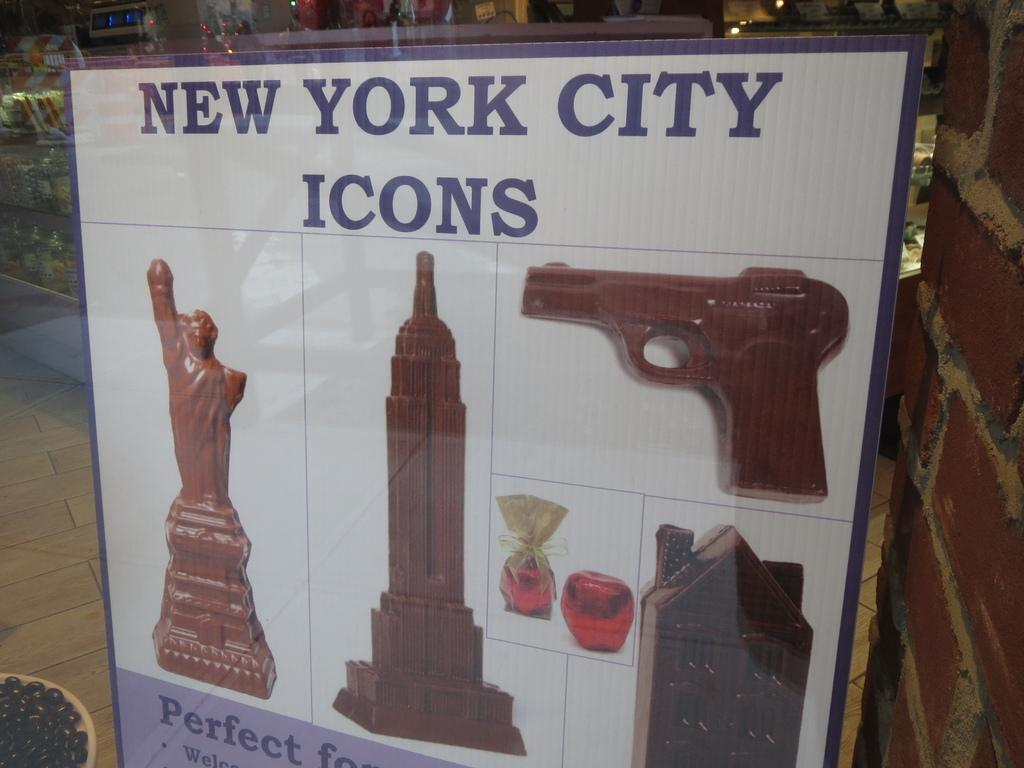<image>
Describe the image concisely. A satirical poster of New York City icons made of chocolate. 